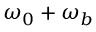<formula> <loc_0><loc_0><loc_500><loc_500>\omega _ { 0 } + \omega _ { b }</formula> 